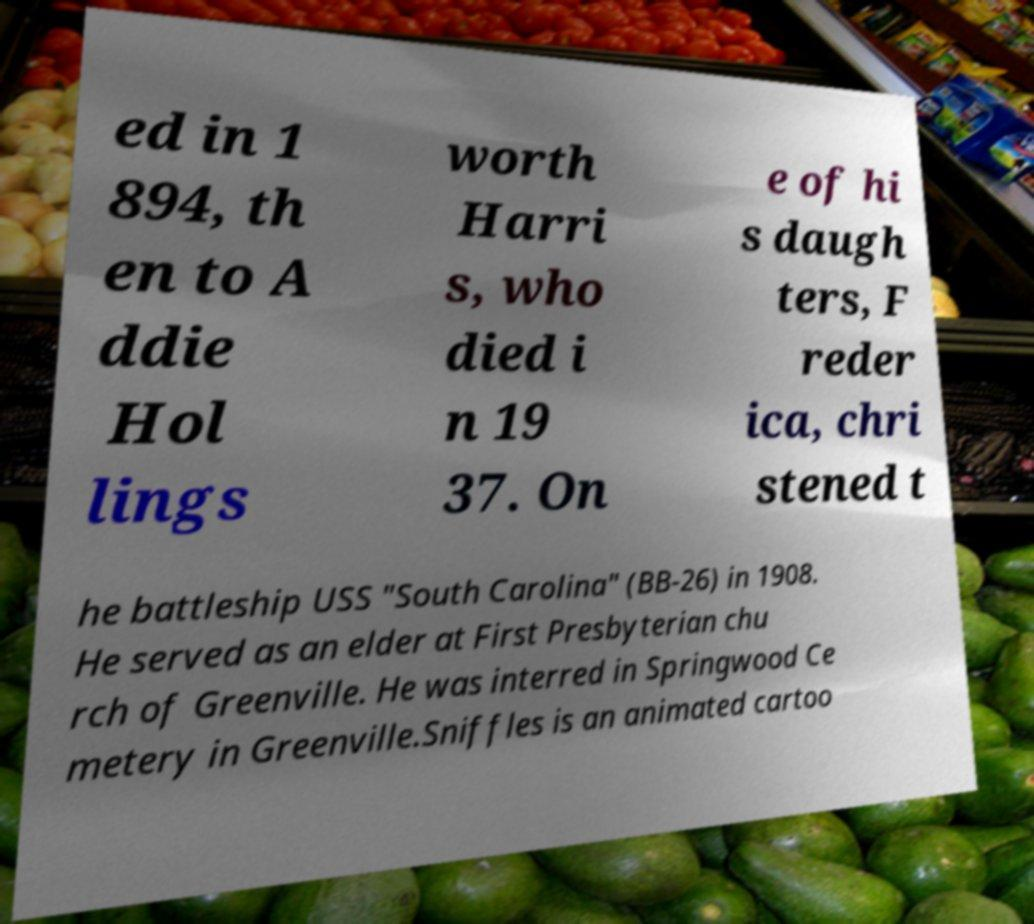Please read and relay the text visible in this image. What does it say? ed in 1 894, th en to A ddie Hol lings worth Harri s, who died i n 19 37. On e of hi s daugh ters, F reder ica, chri stened t he battleship USS "South Carolina" (BB-26) in 1908. He served as an elder at First Presbyterian chu rch of Greenville. He was interred in Springwood Ce metery in Greenville.Sniffles is an animated cartoo 